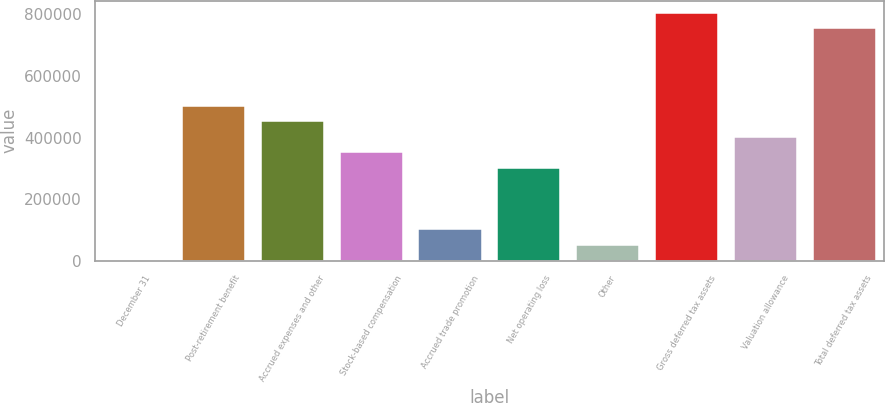<chart> <loc_0><loc_0><loc_500><loc_500><bar_chart><fcel>December 31<fcel>Post-retirement benefit<fcel>Accrued expenses and other<fcel>Stock-based compensation<fcel>Accrued trade promotion<fcel>Net operating loss<fcel>Other<fcel>Gross deferred tax assets<fcel>Valuation allowance<fcel>Total deferred tax assets<nl><fcel>2011<fcel>503112<fcel>453002<fcel>352782<fcel>102231<fcel>302672<fcel>52121.1<fcel>803773<fcel>402892<fcel>753662<nl></chart> 